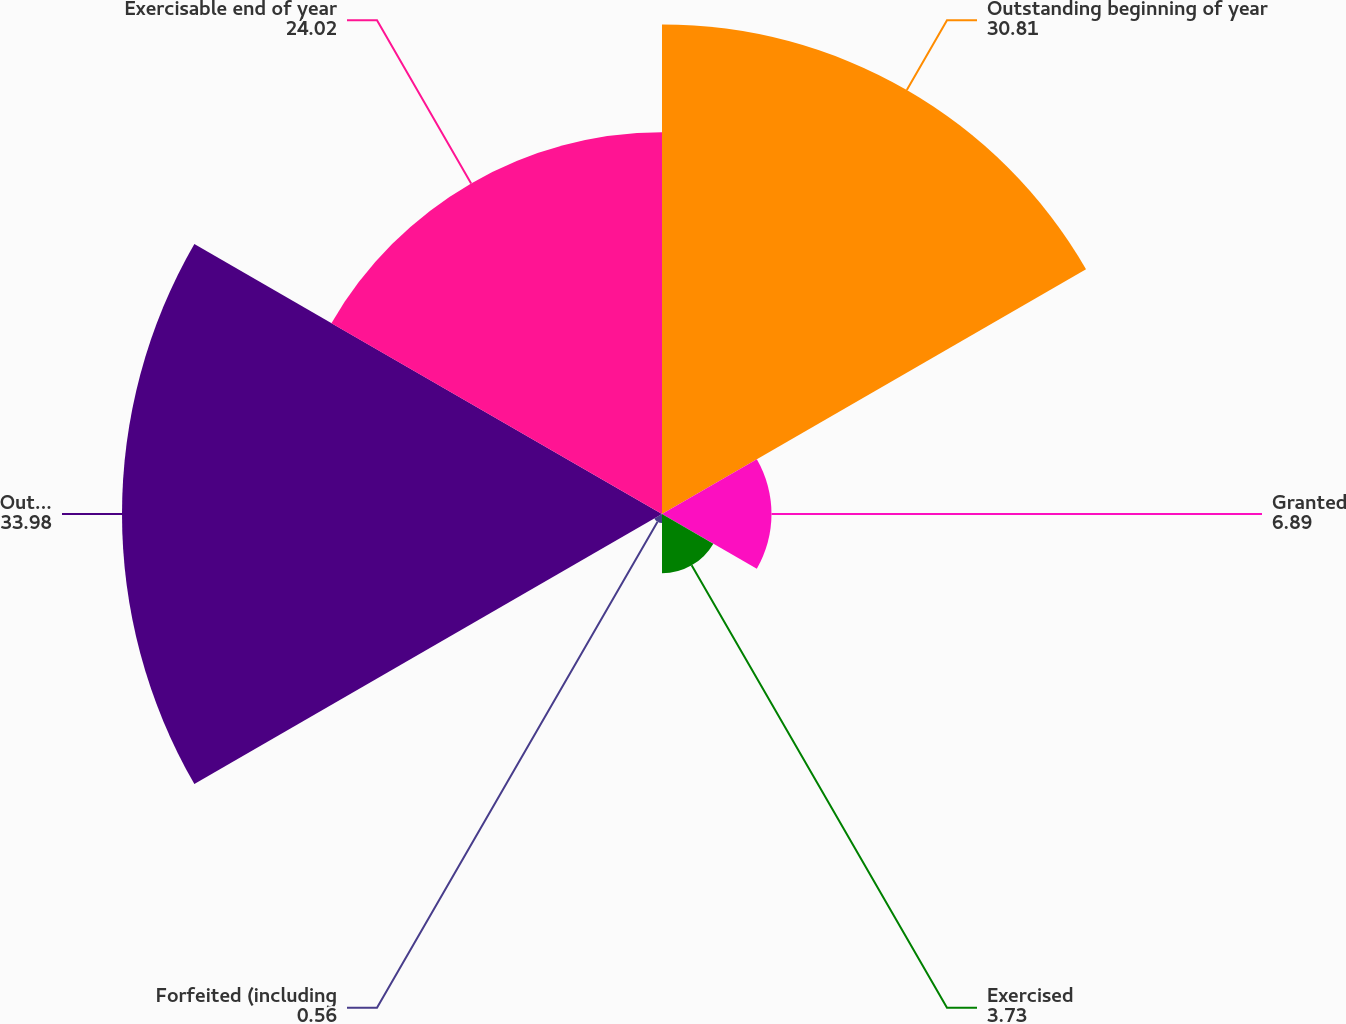<chart> <loc_0><loc_0><loc_500><loc_500><pie_chart><fcel>Outstanding beginning of year<fcel>Granted<fcel>Exercised<fcel>Forfeited (including<fcel>Outstanding end of year<fcel>Exercisable end of year<nl><fcel>30.81%<fcel>6.89%<fcel>3.73%<fcel>0.56%<fcel>33.98%<fcel>24.02%<nl></chart> 